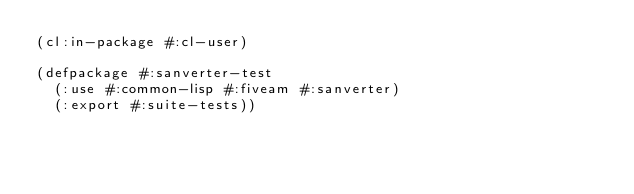<code> <loc_0><loc_0><loc_500><loc_500><_Lisp_>(cl:in-package #:cl-user)

(defpackage #:sanverter-test
  (:use #:common-lisp #:fiveam #:sanverter)
  (:export #:suite-tests))

</code> 